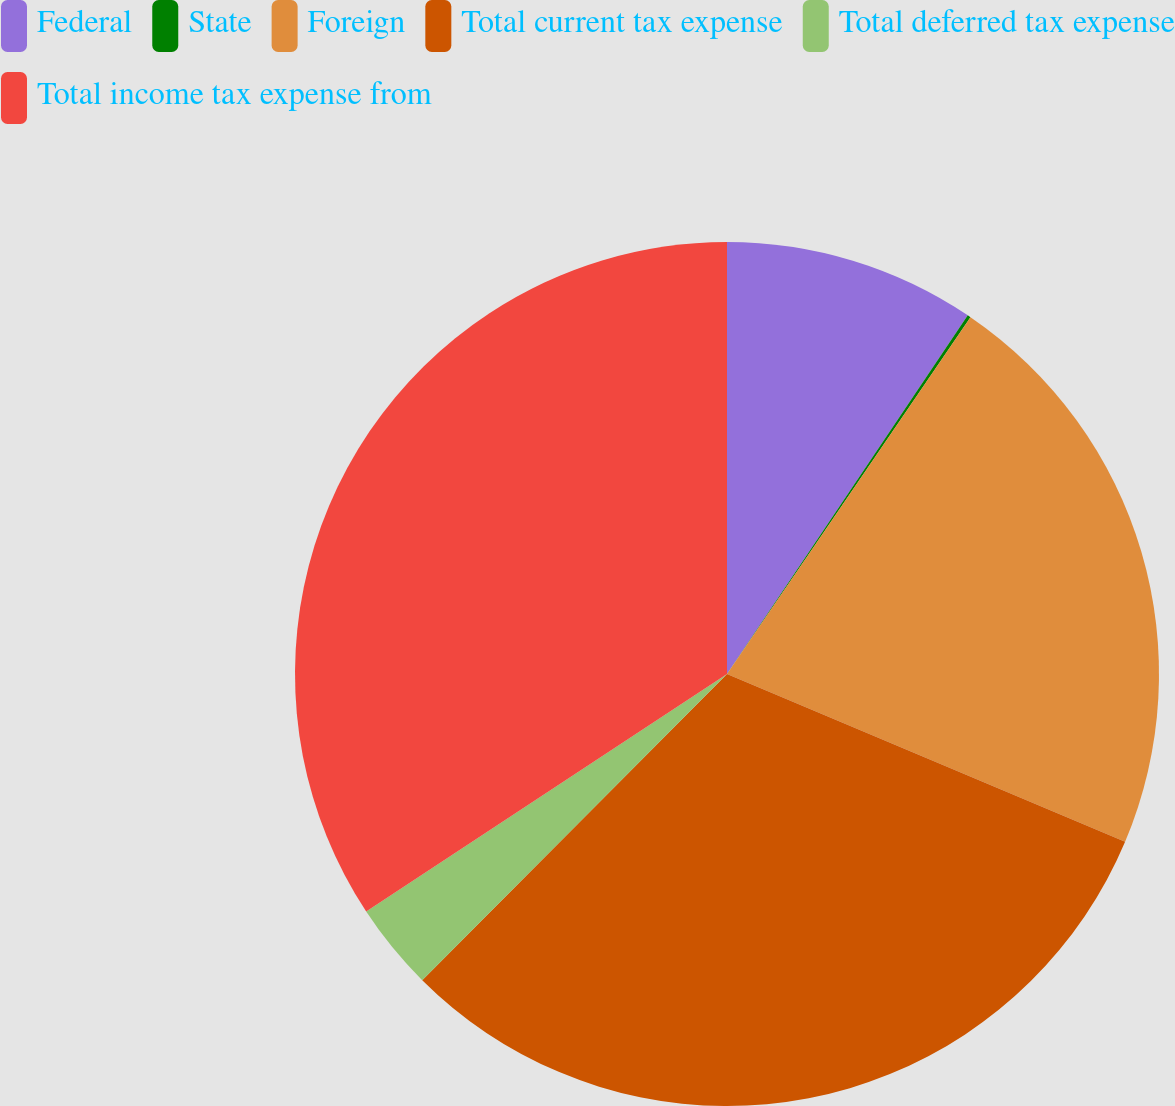<chart> <loc_0><loc_0><loc_500><loc_500><pie_chart><fcel>Federal<fcel>State<fcel>Foreign<fcel>Total current tax expense<fcel>Total deferred tax expense<fcel>Total income tax expense from<nl><fcel>9.41%<fcel>0.12%<fcel>21.82%<fcel>31.12%<fcel>3.27%<fcel>34.27%<nl></chart> 